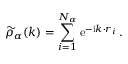<formula> <loc_0><loc_0><loc_500><loc_500>\widetilde { \rho } _ { \alpha } ( k ) = \sum _ { i = 1 } ^ { N _ { \alpha } } e ^ { - i k \cdot r _ { i } } \, .</formula> 